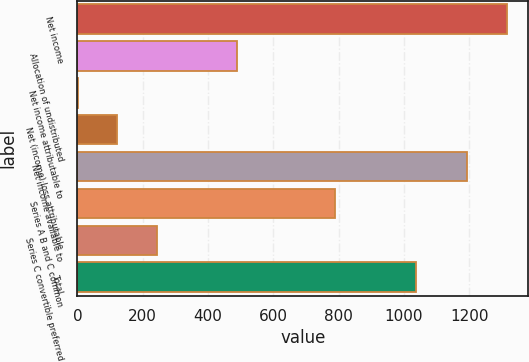Convert chart. <chart><loc_0><loc_0><loc_500><loc_500><bar_chart><fcel>Net income<fcel>Allocation of undistributed<fcel>Net income attributable to<fcel>Net (income) loss attributable<fcel>Net income available to<fcel>Series A B and C common<fcel>Series C convertible preferred<fcel>Total<nl><fcel>1315.7<fcel>487.8<fcel>1<fcel>122.7<fcel>1194<fcel>789<fcel>244.4<fcel>1037.7<nl></chart> 